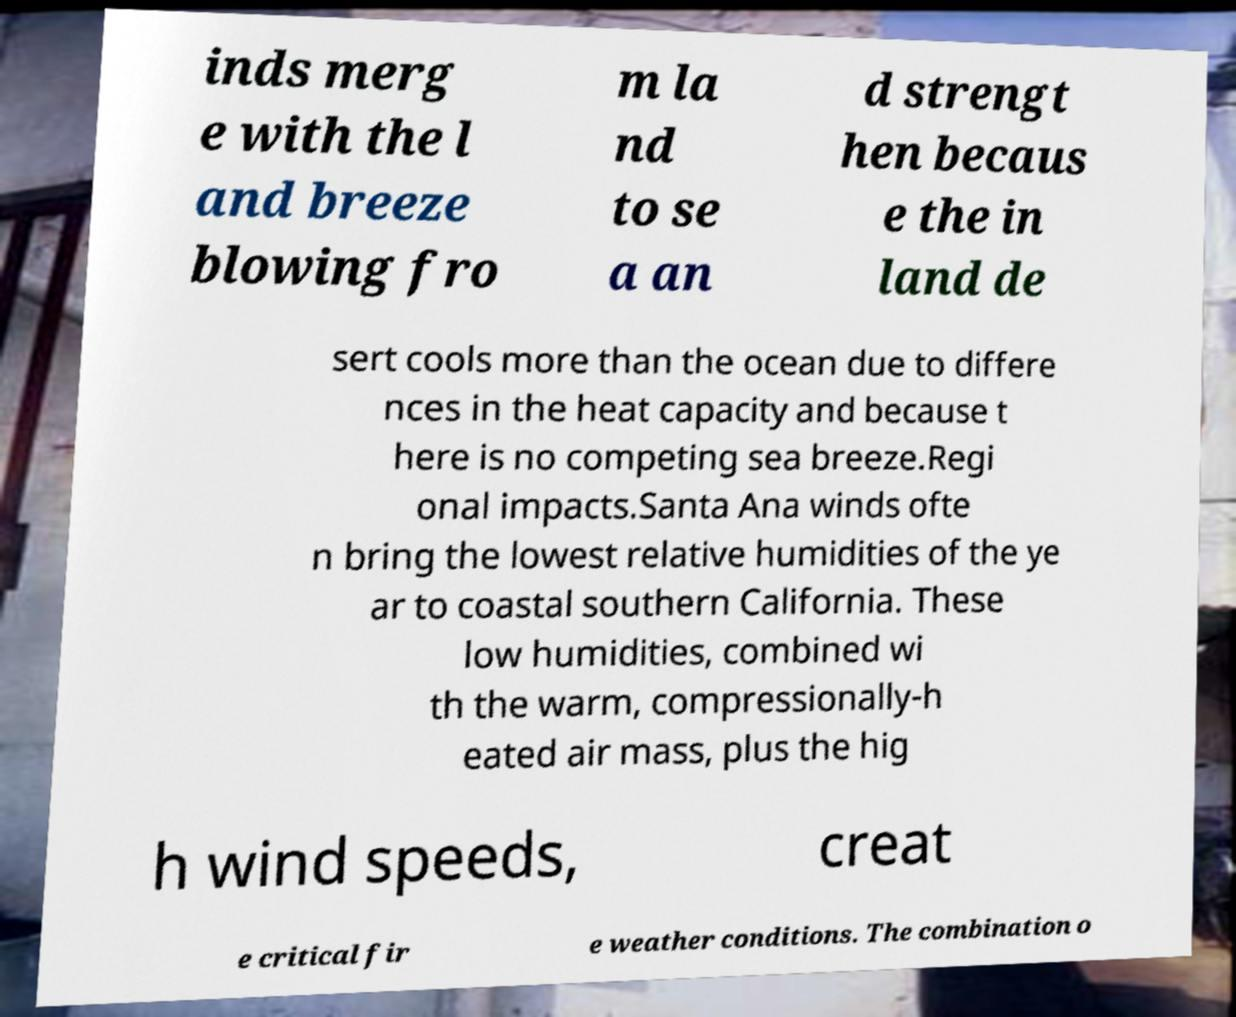I need the written content from this picture converted into text. Can you do that? inds merg e with the l and breeze blowing fro m la nd to se a an d strengt hen becaus e the in land de sert cools more than the ocean due to differe nces in the heat capacity and because t here is no competing sea breeze.Regi onal impacts.Santa Ana winds ofte n bring the lowest relative humidities of the ye ar to coastal southern California. These low humidities, combined wi th the warm, compressionally-h eated air mass, plus the hig h wind speeds, creat e critical fir e weather conditions. The combination o 